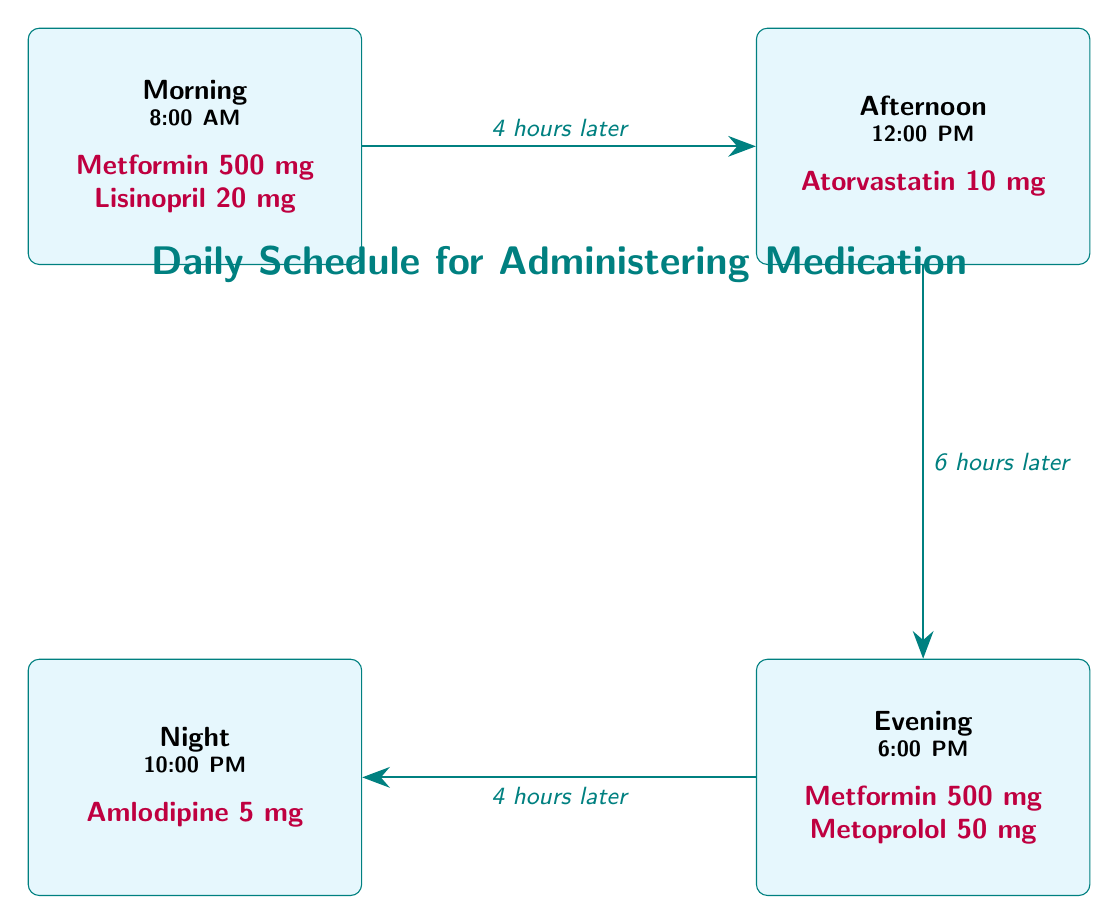What medications are taken in the morning? According to the diagram, the medications listed for the morning at 8:00 AM are Metformin 500 mg and Lisinopril 20 mg.
Answer: Metformin 500 mg, Lisinopril 20 mg How many hours are there between the morning and afternoon medication times? The diagram shows that the medication in the morning (8:00 AM) is followed by the afternoon medication (12:00 PM) with an interval described as "4 hours later."
Answer: 4 hours What is the last medication administered before bedtime? The diagram indicates that the last medication taken is Amlodipine 5 mg, which is scheduled for 10:00 PM.
Answer: Amlodipine 5 mg Which medication is administered at 12:00 PM? The diagram specifies that Atorvastatin 10 mg is the sole medication administered at 12:00 PM in the afternoon section.
Answer: Atorvastatin 10 mg How many different times for medication are represented in the diagram? The diagram displays four different times for medication: Morning at 8:00 AM, Afternoon at 12:00 PM, Evening at 6:00 PM, and Night at 10:00 PM, totaling four times.
Answer: 4 times What is the total dosage of Metformin administered throughout the day? The diagram shows that Metformin is taken twice, once in the morning (500 mg) and once in the evening (500 mg), therefore totaling 1000 mg.
Answer: 1000 mg 